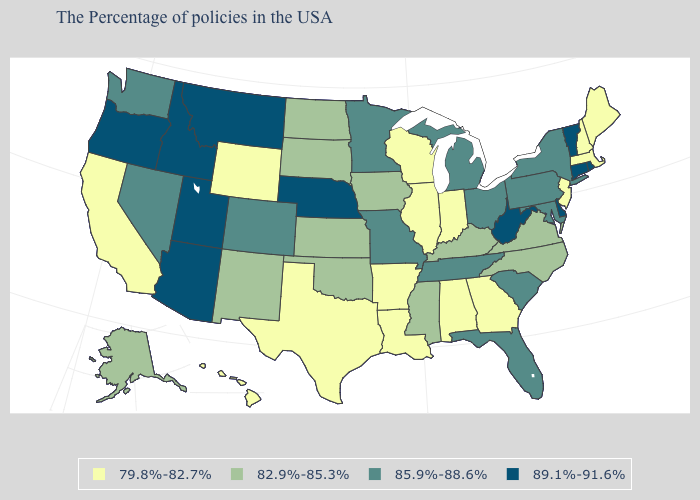What is the value of Tennessee?
Short answer required. 85.9%-88.6%. Name the states that have a value in the range 89.1%-91.6%?
Write a very short answer. Rhode Island, Vermont, Connecticut, Delaware, West Virginia, Nebraska, Utah, Montana, Arizona, Idaho, Oregon. What is the value of Connecticut?
Answer briefly. 89.1%-91.6%. What is the lowest value in states that border Arizona?
Give a very brief answer. 79.8%-82.7%. Name the states that have a value in the range 82.9%-85.3%?
Be succinct. Virginia, North Carolina, Kentucky, Mississippi, Iowa, Kansas, Oklahoma, South Dakota, North Dakota, New Mexico, Alaska. Among the states that border Georgia , which have the highest value?
Answer briefly. South Carolina, Florida, Tennessee. Does the first symbol in the legend represent the smallest category?
Quick response, please. Yes. What is the highest value in the South ?
Quick response, please. 89.1%-91.6%. What is the value of Delaware?
Concise answer only. 89.1%-91.6%. Does Tennessee have a higher value than Minnesota?
Give a very brief answer. No. Name the states that have a value in the range 82.9%-85.3%?
Write a very short answer. Virginia, North Carolina, Kentucky, Mississippi, Iowa, Kansas, Oklahoma, South Dakota, North Dakota, New Mexico, Alaska. Does the map have missing data?
Keep it brief. No. What is the value of Delaware?
Write a very short answer. 89.1%-91.6%. What is the highest value in the USA?
Keep it brief. 89.1%-91.6%. Which states have the highest value in the USA?
Be succinct. Rhode Island, Vermont, Connecticut, Delaware, West Virginia, Nebraska, Utah, Montana, Arizona, Idaho, Oregon. 